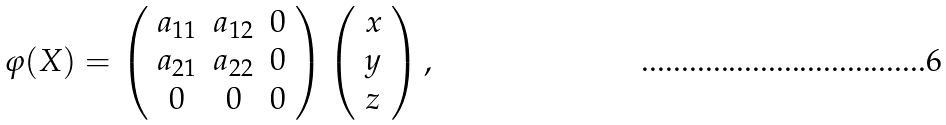<formula> <loc_0><loc_0><loc_500><loc_500>\varphi ( X ) = \left ( \begin{array} { c c c } a _ { 1 1 } & a _ { 1 2 } & 0 \\ a _ { 2 1 } & a _ { 2 2 } & 0 \\ 0 & 0 & 0 \end{array} \right ) \left ( \begin{array} { c c c } x \\ y \\ z \end{array} \right ) ,</formula> 